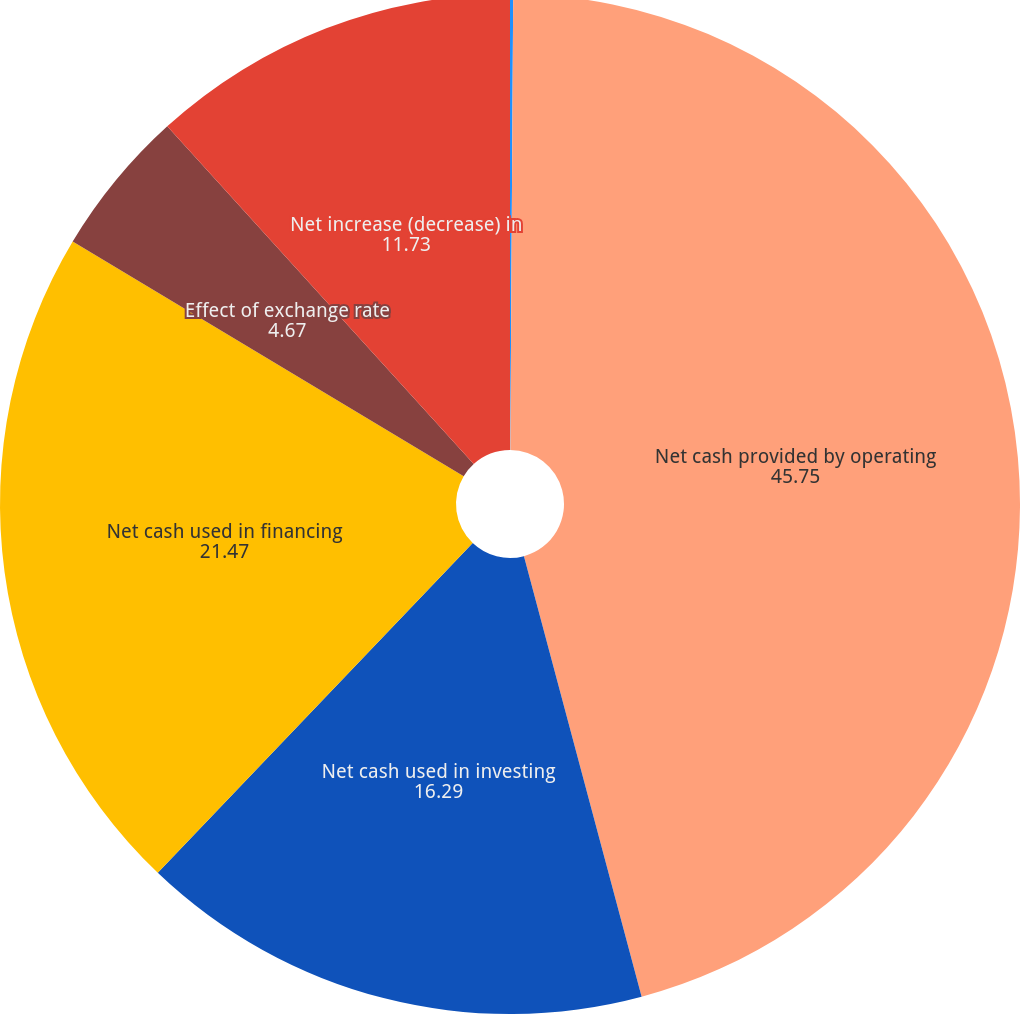Convert chart to OTSL. <chart><loc_0><loc_0><loc_500><loc_500><pie_chart><fcel>(In thousands)<fcel>Net cash provided by operating<fcel>Net cash used in investing<fcel>Net cash used in financing<fcel>Effect of exchange rate<fcel>Net increase (decrease) in<nl><fcel>0.1%<fcel>45.75%<fcel>16.29%<fcel>21.47%<fcel>4.67%<fcel>11.73%<nl></chart> 